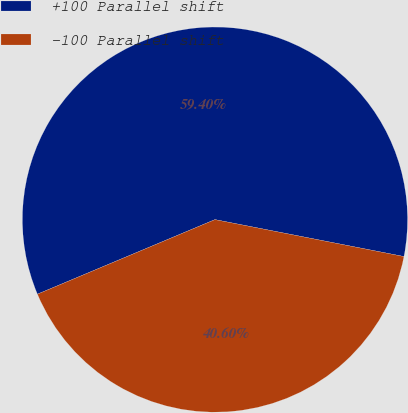<chart> <loc_0><loc_0><loc_500><loc_500><pie_chart><fcel>+100 Parallel shift<fcel>-100 Parallel shift<nl><fcel>59.4%<fcel>40.6%<nl></chart> 